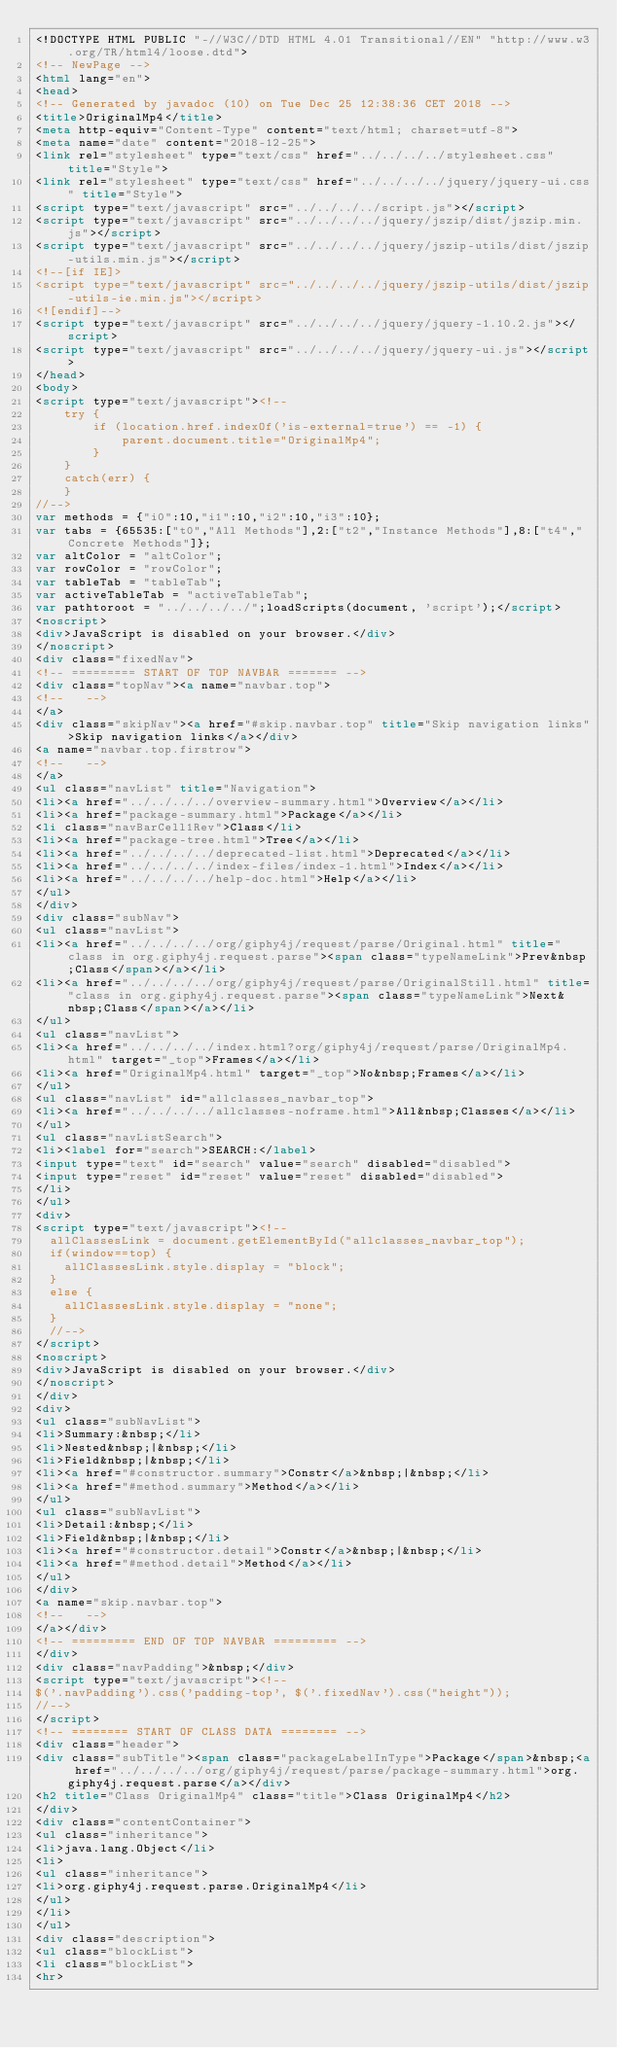<code> <loc_0><loc_0><loc_500><loc_500><_HTML_><!DOCTYPE HTML PUBLIC "-//W3C//DTD HTML 4.01 Transitional//EN" "http://www.w3.org/TR/html4/loose.dtd">
<!-- NewPage -->
<html lang="en">
<head>
<!-- Generated by javadoc (10) on Tue Dec 25 12:38:36 CET 2018 -->
<title>OriginalMp4</title>
<meta http-equiv="Content-Type" content="text/html; charset=utf-8">
<meta name="date" content="2018-12-25">
<link rel="stylesheet" type="text/css" href="../../../../stylesheet.css" title="Style">
<link rel="stylesheet" type="text/css" href="../../../../jquery/jquery-ui.css" title="Style">
<script type="text/javascript" src="../../../../script.js"></script>
<script type="text/javascript" src="../../../../jquery/jszip/dist/jszip.min.js"></script>
<script type="text/javascript" src="../../../../jquery/jszip-utils/dist/jszip-utils.min.js"></script>
<!--[if IE]>
<script type="text/javascript" src="../../../../jquery/jszip-utils/dist/jszip-utils-ie.min.js"></script>
<![endif]-->
<script type="text/javascript" src="../../../../jquery/jquery-1.10.2.js"></script>
<script type="text/javascript" src="../../../../jquery/jquery-ui.js"></script>
</head>
<body>
<script type="text/javascript"><!--
    try {
        if (location.href.indexOf('is-external=true') == -1) {
            parent.document.title="OriginalMp4";
        }
    }
    catch(err) {
    }
//-->
var methods = {"i0":10,"i1":10,"i2":10,"i3":10};
var tabs = {65535:["t0","All Methods"],2:["t2","Instance Methods"],8:["t4","Concrete Methods"]};
var altColor = "altColor";
var rowColor = "rowColor";
var tableTab = "tableTab";
var activeTableTab = "activeTableTab";
var pathtoroot = "../../../../";loadScripts(document, 'script');</script>
<noscript>
<div>JavaScript is disabled on your browser.</div>
</noscript>
<div class="fixedNav">
<!-- ========= START OF TOP NAVBAR ======= -->
<div class="topNav"><a name="navbar.top">
<!--   -->
</a>
<div class="skipNav"><a href="#skip.navbar.top" title="Skip navigation links">Skip navigation links</a></div>
<a name="navbar.top.firstrow">
<!--   -->
</a>
<ul class="navList" title="Navigation">
<li><a href="../../../../overview-summary.html">Overview</a></li>
<li><a href="package-summary.html">Package</a></li>
<li class="navBarCell1Rev">Class</li>
<li><a href="package-tree.html">Tree</a></li>
<li><a href="../../../../deprecated-list.html">Deprecated</a></li>
<li><a href="../../../../index-files/index-1.html">Index</a></li>
<li><a href="../../../../help-doc.html">Help</a></li>
</ul>
</div>
<div class="subNav">
<ul class="navList">
<li><a href="../../../../org/giphy4j/request/parse/Original.html" title="class in org.giphy4j.request.parse"><span class="typeNameLink">Prev&nbsp;Class</span></a></li>
<li><a href="../../../../org/giphy4j/request/parse/OriginalStill.html" title="class in org.giphy4j.request.parse"><span class="typeNameLink">Next&nbsp;Class</span></a></li>
</ul>
<ul class="navList">
<li><a href="../../../../index.html?org/giphy4j/request/parse/OriginalMp4.html" target="_top">Frames</a></li>
<li><a href="OriginalMp4.html" target="_top">No&nbsp;Frames</a></li>
</ul>
<ul class="navList" id="allclasses_navbar_top">
<li><a href="../../../../allclasses-noframe.html">All&nbsp;Classes</a></li>
</ul>
<ul class="navListSearch">
<li><label for="search">SEARCH:</label>
<input type="text" id="search" value="search" disabled="disabled">
<input type="reset" id="reset" value="reset" disabled="disabled">
</li>
</ul>
<div>
<script type="text/javascript"><!--
  allClassesLink = document.getElementById("allclasses_navbar_top");
  if(window==top) {
    allClassesLink.style.display = "block";
  }
  else {
    allClassesLink.style.display = "none";
  }
  //-->
</script>
<noscript>
<div>JavaScript is disabled on your browser.</div>
</noscript>
</div>
<div>
<ul class="subNavList">
<li>Summary:&nbsp;</li>
<li>Nested&nbsp;|&nbsp;</li>
<li>Field&nbsp;|&nbsp;</li>
<li><a href="#constructor.summary">Constr</a>&nbsp;|&nbsp;</li>
<li><a href="#method.summary">Method</a></li>
</ul>
<ul class="subNavList">
<li>Detail:&nbsp;</li>
<li>Field&nbsp;|&nbsp;</li>
<li><a href="#constructor.detail">Constr</a>&nbsp;|&nbsp;</li>
<li><a href="#method.detail">Method</a></li>
</ul>
</div>
<a name="skip.navbar.top">
<!--   -->
</a></div>
<!-- ========= END OF TOP NAVBAR ========= -->
</div>
<div class="navPadding">&nbsp;</div>
<script type="text/javascript"><!--
$('.navPadding').css('padding-top', $('.fixedNav').css("height"));
//-->
</script>
<!-- ======== START OF CLASS DATA ======== -->
<div class="header">
<div class="subTitle"><span class="packageLabelInType">Package</span>&nbsp;<a href="../../../../org/giphy4j/request/parse/package-summary.html">org.giphy4j.request.parse</a></div>
<h2 title="Class OriginalMp4" class="title">Class OriginalMp4</h2>
</div>
<div class="contentContainer">
<ul class="inheritance">
<li>java.lang.Object</li>
<li>
<ul class="inheritance">
<li>org.giphy4j.request.parse.OriginalMp4</li>
</ul>
</li>
</ul>
<div class="description">
<ul class="blockList">
<li class="blockList">
<hr></code> 